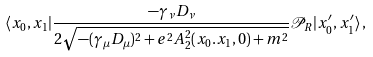<formula> <loc_0><loc_0><loc_500><loc_500>\langle x _ { 0 } , x _ { 1 } | \frac { - \gamma _ { \nu } D _ { \nu } } { 2 \sqrt { - ( \gamma _ { \mu } D _ { \mu } ) ^ { 2 } + e ^ { 2 } A _ { 2 } ^ { 2 } ( x _ { 0 } . x _ { 1 } , 0 ) + m ^ { 2 } } } { \mathcal { P } } _ { R } | x _ { 0 } ^ { \prime } , x _ { 1 } ^ { \prime } \rangle \, ,</formula> 